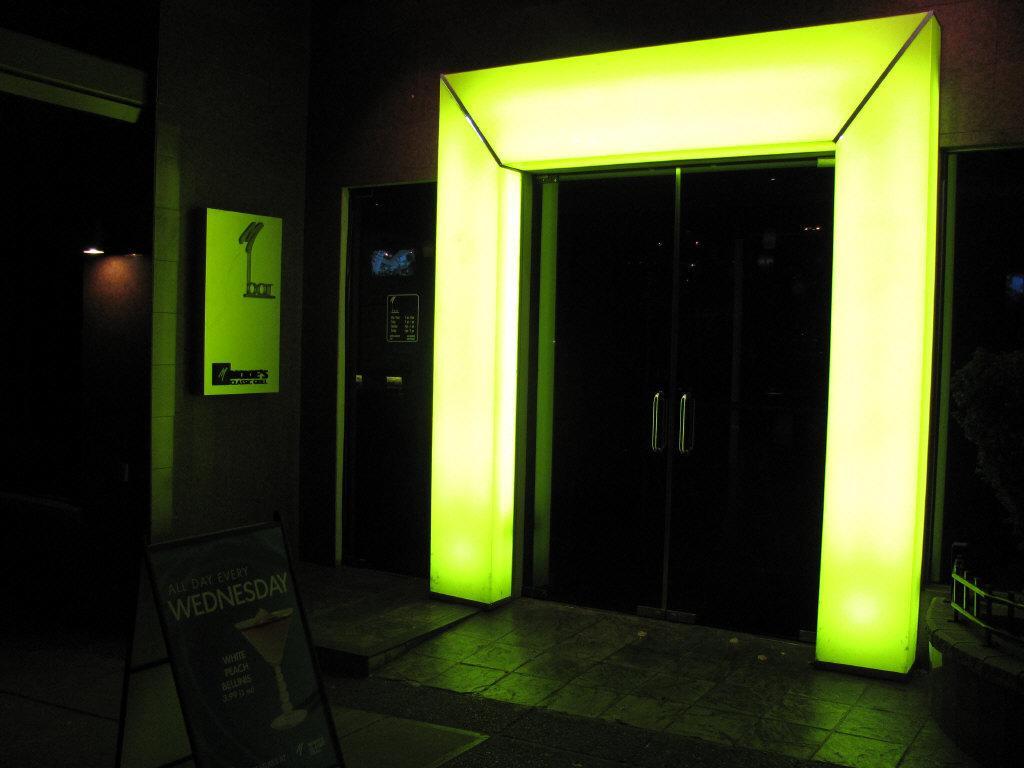Describe this image in one or two sentences. This image consists of a board at the bottom. There is a door in the middle. There is light on the left side. 